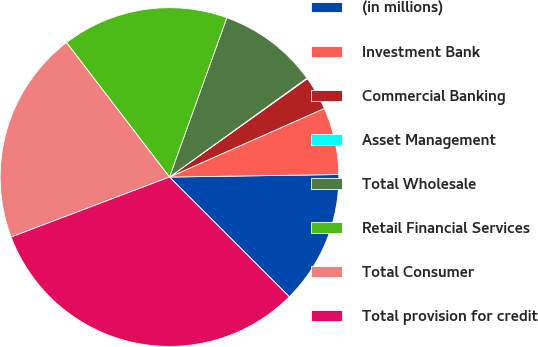Convert chart. <chart><loc_0><loc_0><loc_500><loc_500><pie_chart><fcel>(in millions)<fcel>Investment Bank<fcel>Commercial Banking<fcel>Asset Management<fcel>Total Wholesale<fcel>Retail Financial Services<fcel>Total Consumer<fcel>Total provision for credit<nl><fcel>12.73%<fcel>6.4%<fcel>3.23%<fcel>0.06%<fcel>9.57%<fcel>15.9%<fcel>20.36%<fcel>31.74%<nl></chart> 